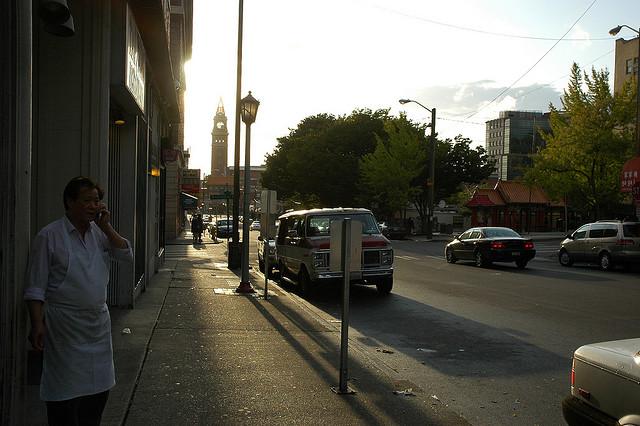What industry does the man work in?
Answer briefly. Food. What is behind the food truck?
Write a very short answer. Car. How many vans are pictured?
Be succinct. 1. Where is the sun?
Quick response, please. Behind building. 